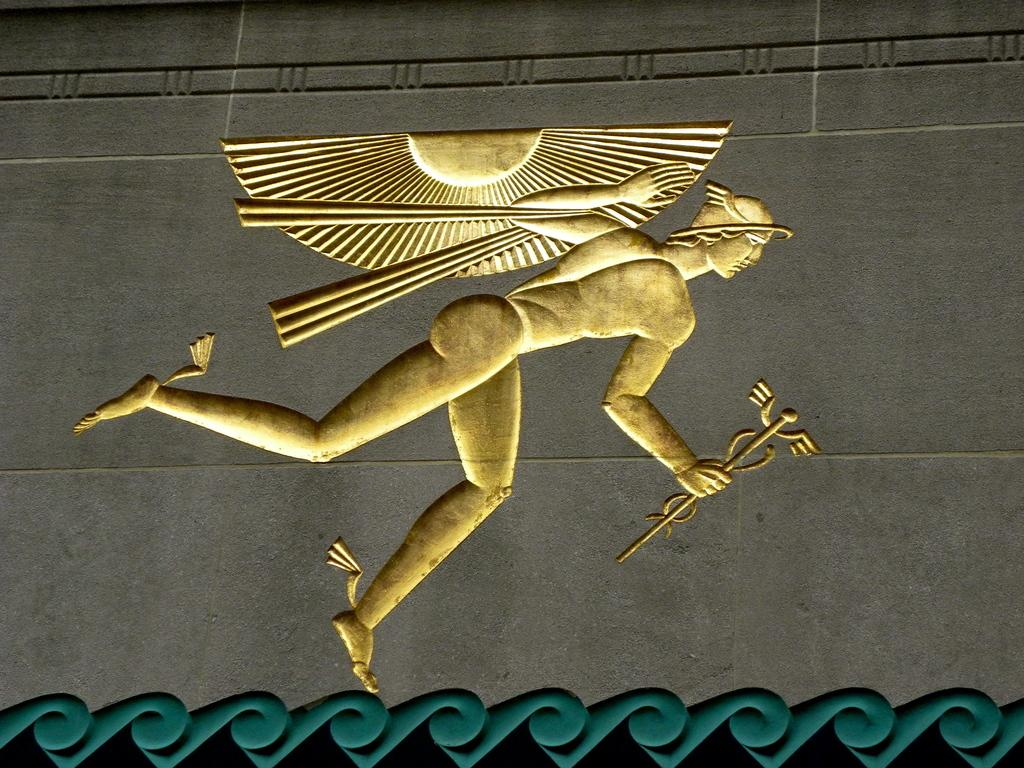What is the main subject of the image? There is a picture of a man in the image. What is the man doing in the image? The man is holding an object. What can be seen behind the man in the image? There is a wall visible on the backside of the image. Can you see a zephyr in the image? There is no zephyr present in the image; a zephyr refers to a gentle breeze, which is not a visible object. 